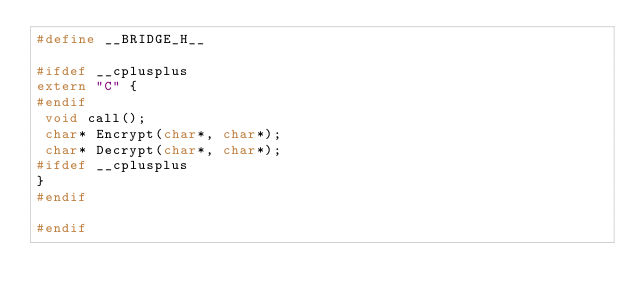Convert code to text. <code><loc_0><loc_0><loc_500><loc_500><_C_>#define __BRIDGE_H__

#ifdef __cplusplus
extern "C" {
#endif
 void call();
 char* Encrypt(char*, char*);
 char* Decrypt(char*, char*);
#ifdef __cplusplus
}
#endif

#endif</code> 